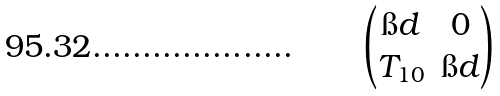<formula> <loc_0><loc_0><loc_500><loc_500>\begin{pmatrix} \i d & 0 \\ T _ { 1 0 } & \i d \end{pmatrix}</formula> 